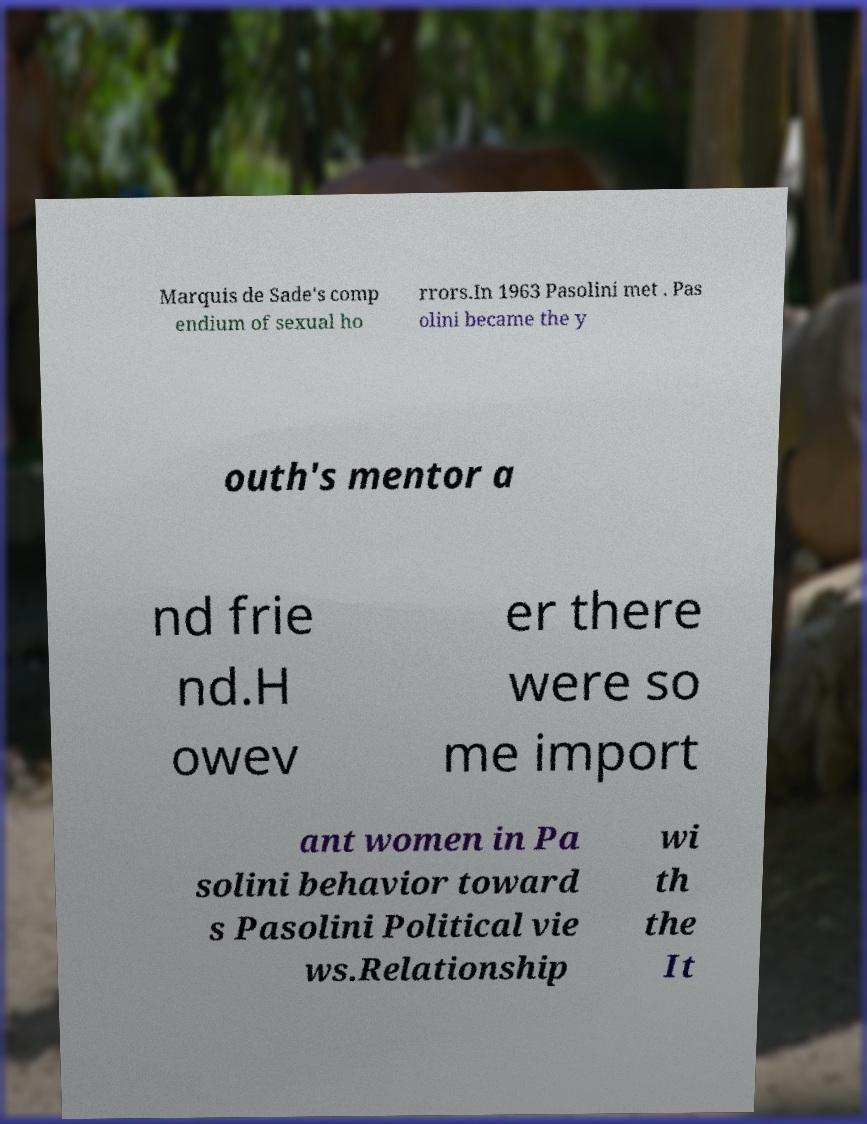Please identify and transcribe the text found in this image. Marquis de Sade's comp endium of sexual ho rrors.In 1963 Pasolini met . Pas olini became the y outh's mentor a nd frie nd.H owev er there were so me import ant women in Pa solini behavior toward s Pasolini Political vie ws.Relationship wi th the It 